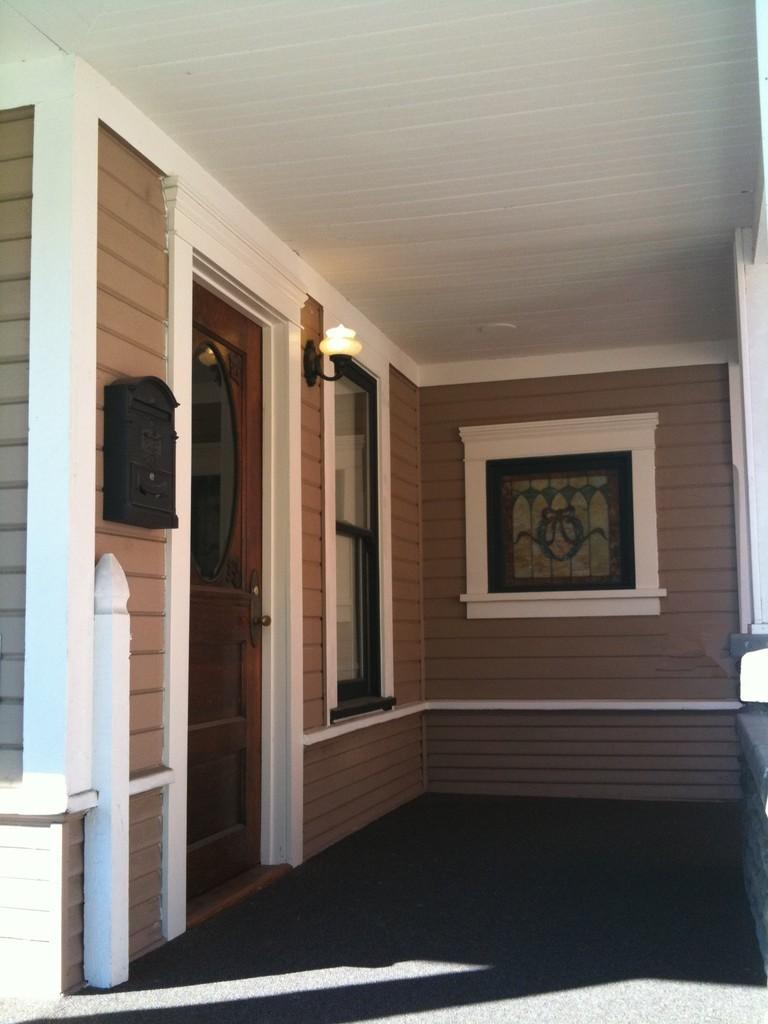Describe this image in one or two sentences. Here we can see door,window,an object and light on the wall,ceiling and this is floor. 